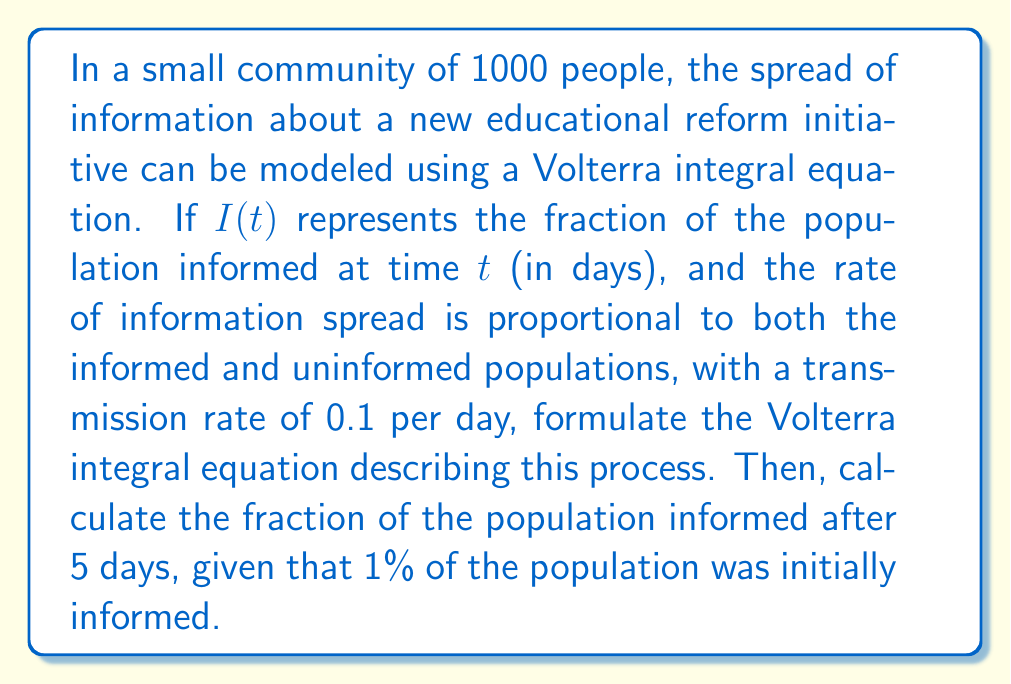What is the answer to this math problem? 1) First, let's formulate the Volterra integral equation:

   The rate of change of the informed population is given by:
   $$\frac{dI}{dt} = 0.1 \cdot I(t) \cdot (1 - I(t))$$

2) Integrating both sides from 0 to t:
   $$I(t) - I(0) = 0.1 \int_0^t I(s)(1-I(s))ds$$

3) This is our Volterra integral equation:
   $$I(t) = I(0) + 0.1 \int_0^t I(s)(1-I(s))ds$$

4) We're given that I(0) = 0.01 (1% initially informed), so:
   $$I(t) = 0.01 + 0.1 \int_0^t I(s)(1-I(s))ds$$

5) To solve this for t = 5, we need to use numerical methods. Let's use Euler's method with a step size of 0.1 days:

6) For each step:
   $$I(t+h) = I(t) + h \cdot 0.1 \cdot I(t) \cdot (1-I(t))$$

7) Applying this iteratively:
   t = 0: I(0) = 0.01
   t = 0.1: I(0.1) ≈ 0.01 + 0.1 * 0.1 * 0.01 * 0.99 = 0.0101
   t = 0.2: I(0.2) ≈ 0.0101 + 0.1 * 0.1 * 0.0101 * 0.9899 = 0.0102
   ...
   t = 5: I(5) ≈ 0.0612

8) Therefore, after 5 days, approximately 6.12% of the population is informed.
Answer: 0.0612 or 6.12% 